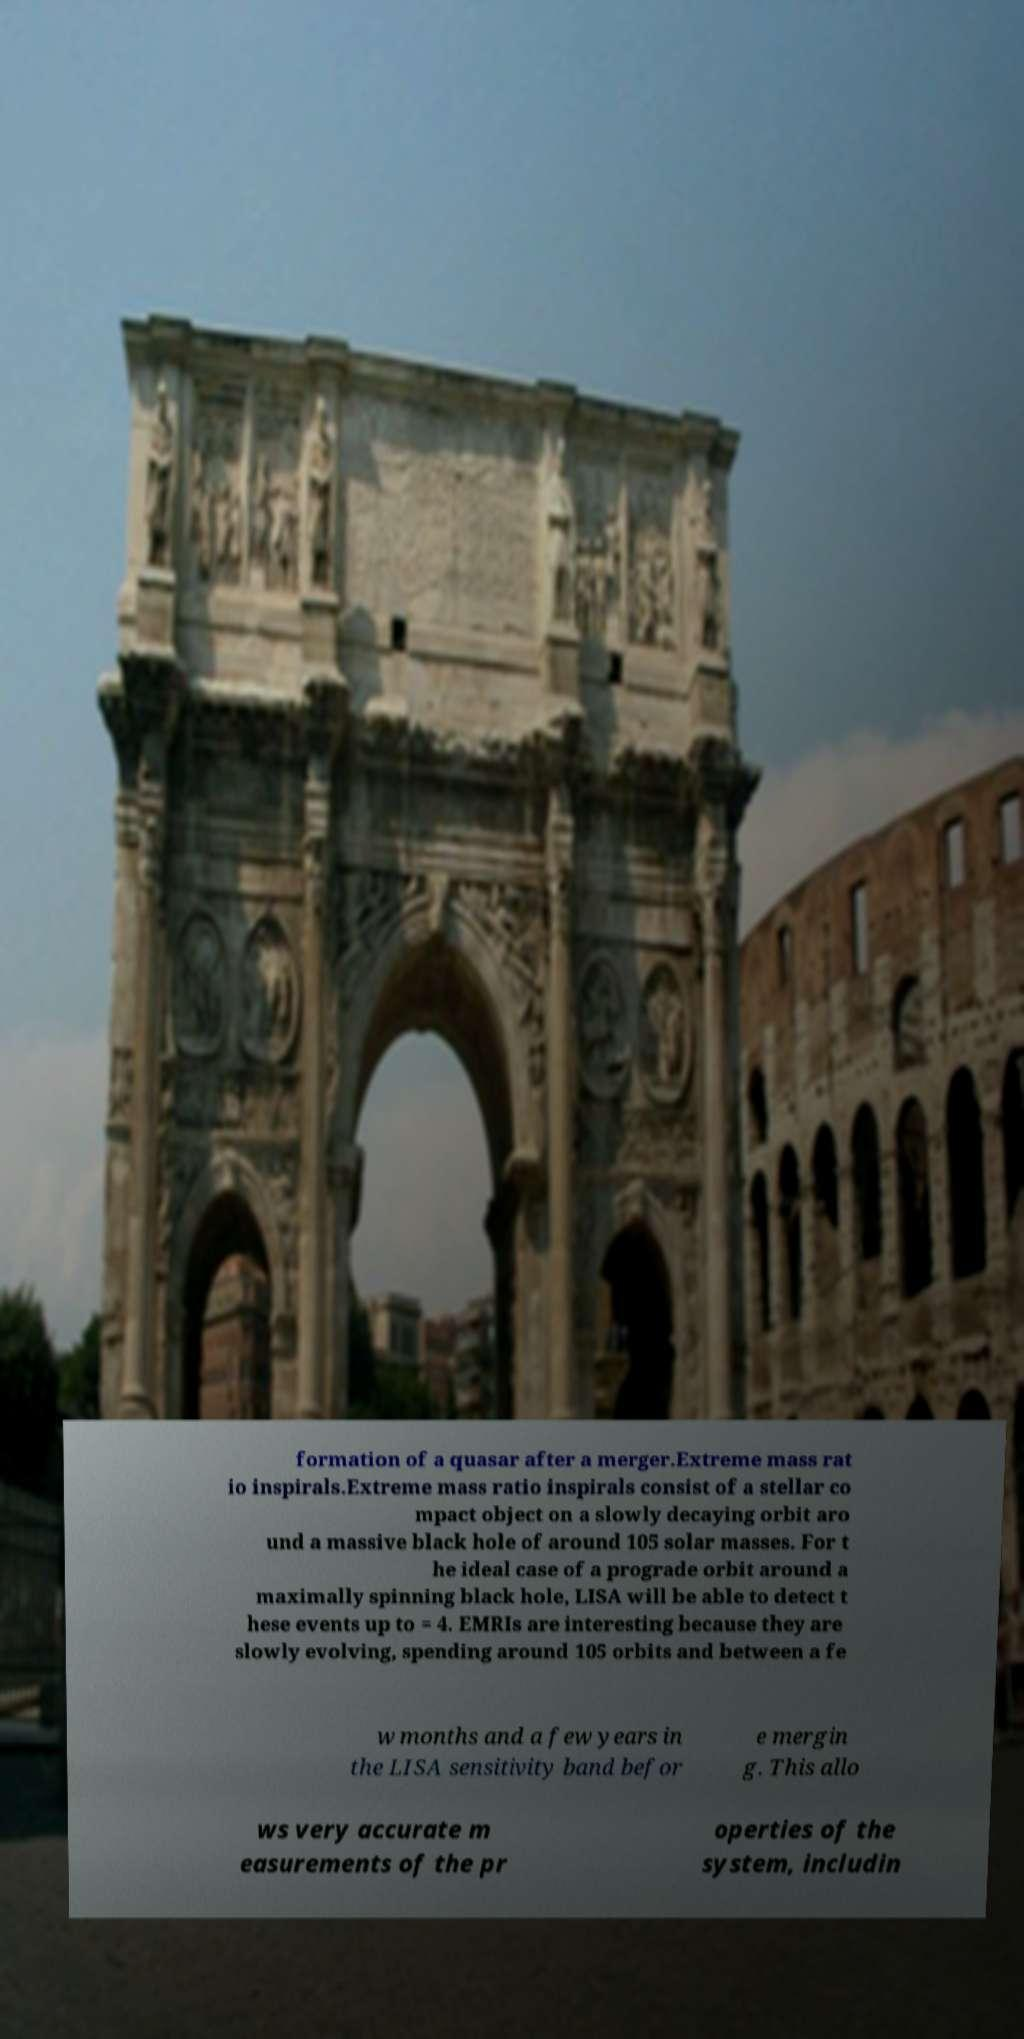Please identify and transcribe the text found in this image. formation of a quasar after a merger.Extreme mass rat io inspirals.Extreme mass ratio inspirals consist of a stellar co mpact object on a slowly decaying orbit aro und a massive black hole of around 105 solar masses. For t he ideal case of a prograde orbit around a maximally spinning black hole, LISA will be able to detect t hese events up to = 4. EMRIs are interesting because they are slowly evolving, spending around 105 orbits and between a fe w months and a few years in the LISA sensitivity band befor e mergin g. This allo ws very accurate m easurements of the pr operties of the system, includin 